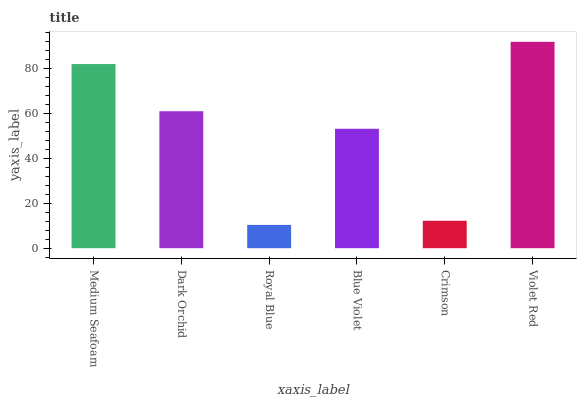Is Royal Blue the minimum?
Answer yes or no. Yes. Is Violet Red the maximum?
Answer yes or no. Yes. Is Dark Orchid the minimum?
Answer yes or no. No. Is Dark Orchid the maximum?
Answer yes or no. No. Is Medium Seafoam greater than Dark Orchid?
Answer yes or no. Yes. Is Dark Orchid less than Medium Seafoam?
Answer yes or no. Yes. Is Dark Orchid greater than Medium Seafoam?
Answer yes or no. No. Is Medium Seafoam less than Dark Orchid?
Answer yes or no. No. Is Dark Orchid the high median?
Answer yes or no. Yes. Is Blue Violet the low median?
Answer yes or no. Yes. Is Medium Seafoam the high median?
Answer yes or no. No. Is Crimson the low median?
Answer yes or no. No. 